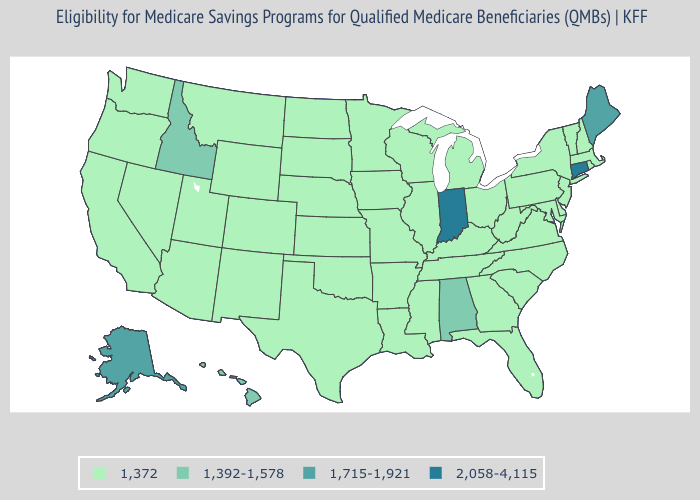Does the map have missing data?
Short answer required. No. Does West Virginia have the highest value in the South?
Keep it brief. No. What is the value of Indiana?
Give a very brief answer. 2,058-4,115. Which states hav the highest value in the Northeast?
Quick response, please. Connecticut. What is the highest value in the MidWest ?
Quick response, please. 2,058-4,115. Name the states that have a value in the range 1,372?
Be succinct. Arizona, Arkansas, California, Colorado, Delaware, Florida, Georgia, Illinois, Iowa, Kansas, Kentucky, Louisiana, Maryland, Massachusetts, Michigan, Minnesota, Mississippi, Missouri, Montana, Nebraska, Nevada, New Hampshire, New Jersey, New Mexico, New York, North Carolina, North Dakota, Ohio, Oklahoma, Oregon, Pennsylvania, Rhode Island, South Carolina, South Dakota, Tennessee, Texas, Utah, Vermont, Virginia, Washington, West Virginia, Wisconsin, Wyoming. Does the map have missing data?
Short answer required. No. Is the legend a continuous bar?
Write a very short answer. No. What is the value of Utah?
Give a very brief answer. 1,372. Name the states that have a value in the range 1,392-1,578?
Answer briefly. Alabama, Hawaii, Idaho. Among the states that border Utah , which have the lowest value?
Quick response, please. Arizona, Colorado, Nevada, New Mexico, Wyoming. Among the states that border Wyoming , which have the lowest value?
Keep it brief. Colorado, Montana, Nebraska, South Dakota, Utah. Which states have the lowest value in the South?
Keep it brief. Arkansas, Delaware, Florida, Georgia, Kentucky, Louisiana, Maryland, Mississippi, North Carolina, Oklahoma, South Carolina, Tennessee, Texas, Virginia, West Virginia. What is the value of Virginia?
Quick response, please. 1,372. 